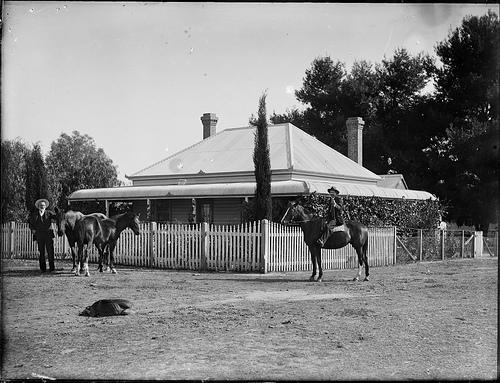What color is the photo?
Be succinct. Black and white. What is the primary source of heating in this house?
Keep it brief. Fireplace. How many horses are pictured?
Short answer required. 3. 